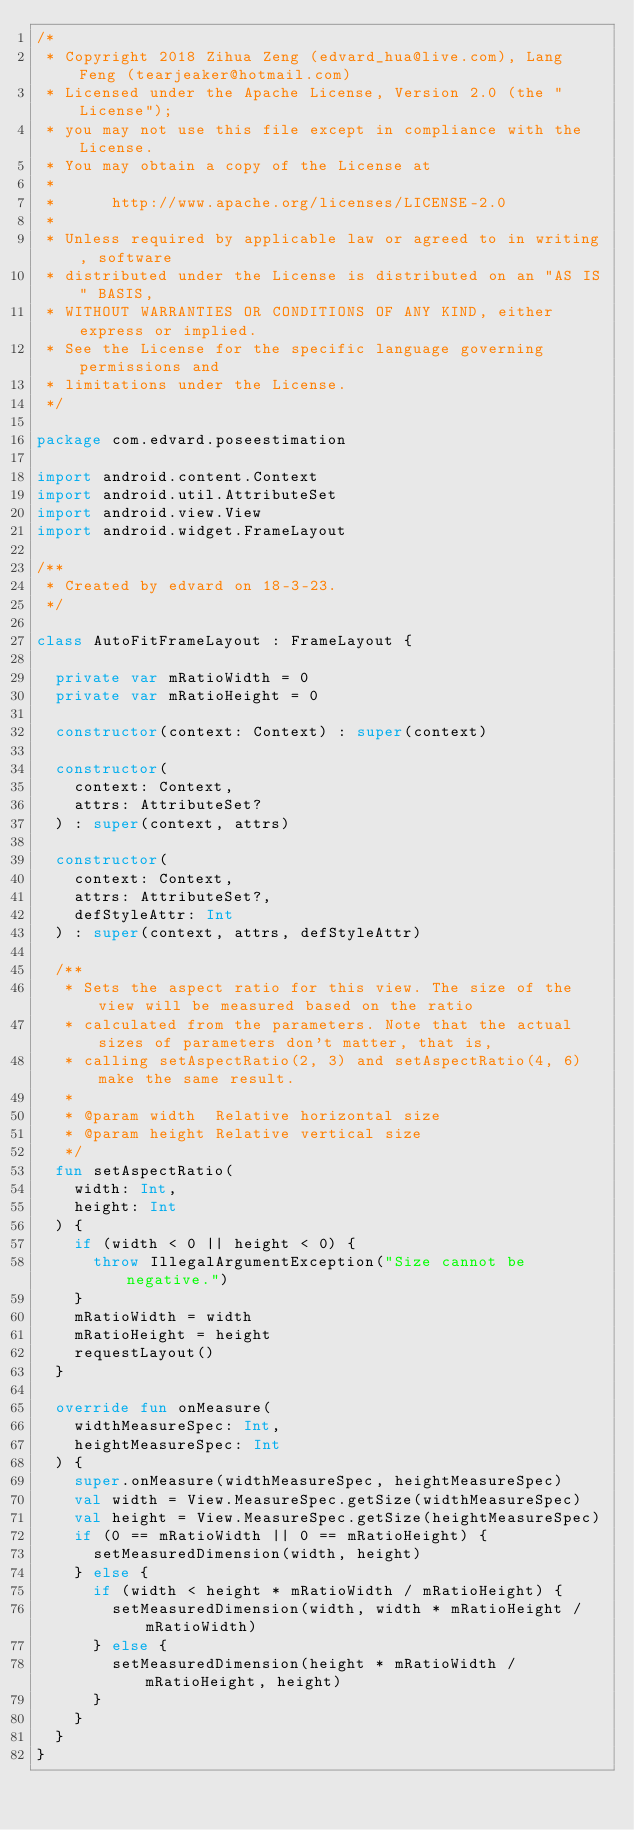Convert code to text. <code><loc_0><loc_0><loc_500><loc_500><_Kotlin_>/*
 * Copyright 2018 Zihua Zeng (edvard_hua@live.com), Lang Feng (tearjeaker@hotmail.com)
 * Licensed under the Apache License, Version 2.0 (the "License");
 * you may not use this file except in compliance with the License.
 * You may obtain a copy of the License at
 *
 *      http://www.apache.org/licenses/LICENSE-2.0
 *
 * Unless required by applicable law or agreed to in writing, software
 * distributed under the License is distributed on an "AS IS" BASIS,
 * WITHOUT WARRANTIES OR CONDITIONS OF ANY KIND, either express or implied.
 * See the License for the specific language governing permissions and
 * limitations under the License.
 */

package com.edvard.poseestimation

import android.content.Context
import android.util.AttributeSet
import android.view.View
import android.widget.FrameLayout

/**
 * Created by edvard on 18-3-23.
 */

class AutoFitFrameLayout : FrameLayout {

  private var mRatioWidth = 0
  private var mRatioHeight = 0

  constructor(context: Context) : super(context)

  constructor(
    context: Context,
    attrs: AttributeSet?
  ) : super(context, attrs)

  constructor(
    context: Context,
    attrs: AttributeSet?,
    defStyleAttr: Int
  ) : super(context, attrs, defStyleAttr)

  /**
   * Sets the aspect ratio for this view. The size of the view will be measured based on the ratio
   * calculated from the parameters. Note that the actual sizes of parameters don't matter, that is,
   * calling setAspectRatio(2, 3) and setAspectRatio(4, 6) make the same result.
   *
   * @param width  Relative horizontal size
   * @param height Relative vertical size
   */
  fun setAspectRatio(
    width: Int,
    height: Int
  ) {
    if (width < 0 || height < 0) {
      throw IllegalArgumentException("Size cannot be negative.")
    }
    mRatioWidth = width
    mRatioHeight = height
    requestLayout()
  }

  override fun onMeasure(
    widthMeasureSpec: Int,
    heightMeasureSpec: Int
  ) {
    super.onMeasure(widthMeasureSpec, heightMeasureSpec)
    val width = View.MeasureSpec.getSize(widthMeasureSpec)
    val height = View.MeasureSpec.getSize(heightMeasureSpec)
    if (0 == mRatioWidth || 0 == mRatioHeight) {
      setMeasuredDimension(width, height)
    } else {
      if (width < height * mRatioWidth / mRatioHeight) {
        setMeasuredDimension(width, width * mRatioHeight / mRatioWidth)
      } else {
        setMeasuredDimension(height * mRatioWidth / mRatioHeight, height)
      }
    }
  }
}
</code> 